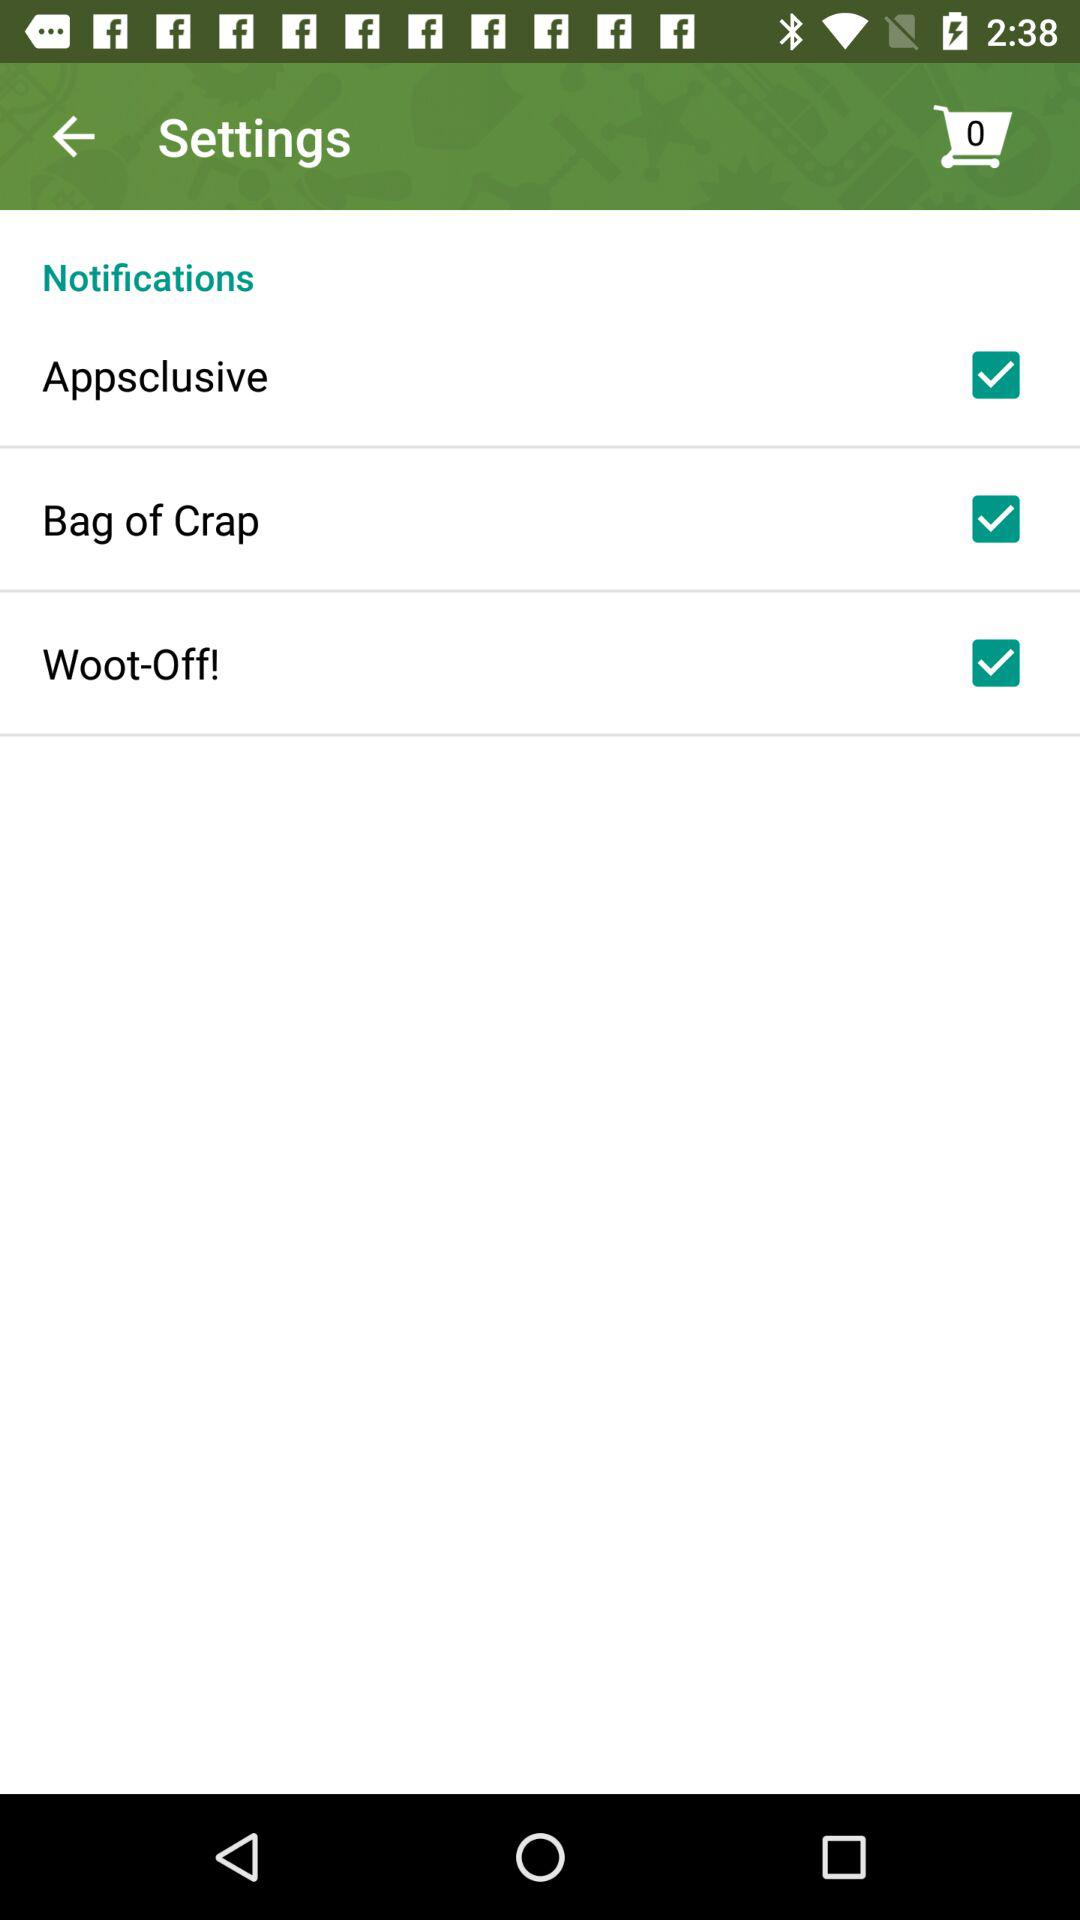What is the status of the woot off? The status is on. 